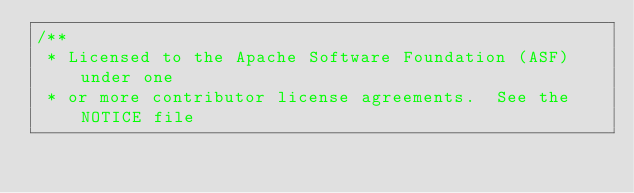Convert code to text. <code><loc_0><loc_0><loc_500><loc_500><_Java_>/**
 * Licensed to the Apache Software Foundation (ASF) under one
 * or more contributor license agreements.  See the NOTICE file</code> 